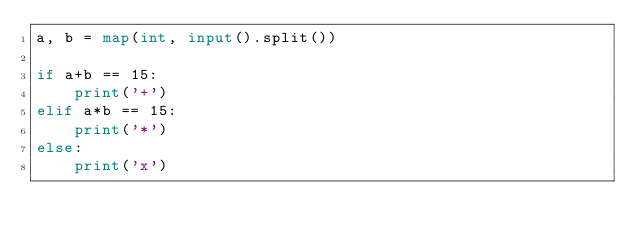Convert code to text. <code><loc_0><loc_0><loc_500><loc_500><_Python_>a, b = map(int, input().split())

if a+b == 15:
    print('+')
elif a*b == 15:
    print('*')
else:
    print('x')
</code> 